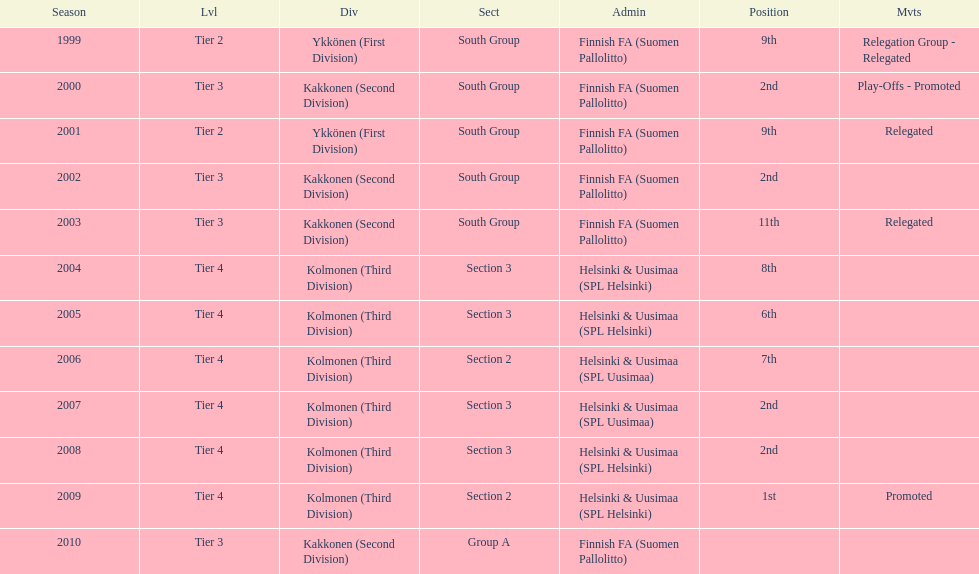Which administration has the least amount of division? Helsinki & Uusimaa (SPL Helsinki). 